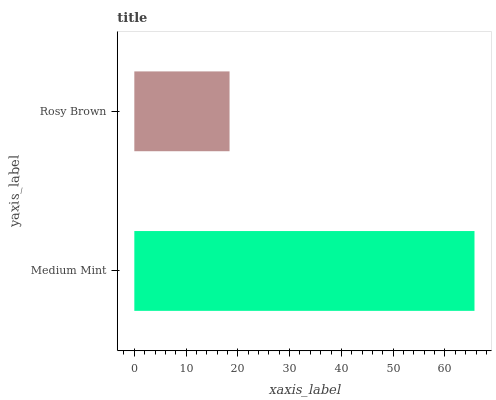Is Rosy Brown the minimum?
Answer yes or no. Yes. Is Medium Mint the maximum?
Answer yes or no. Yes. Is Rosy Brown the maximum?
Answer yes or no. No. Is Medium Mint greater than Rosy Brown?
Answer yes or no. Yes. Is Rosy Brown less than Medium Mint?
Answer yes or no. Yes. Is Rosy Brown greater than Medium Mint?
Answer yes or no. No. Is Medium Mint less than Rosy Brown?
Answer yes or no. No. Is Medium Mint the high median?
Answer yes or no. Yes. Is Rosy Brown the low median?
Answer yes or no. Yes. Is Rosy Brown the high median?
Answer yes or no. No. Is Medium Mint the low median?
Answer yes or no. No. 